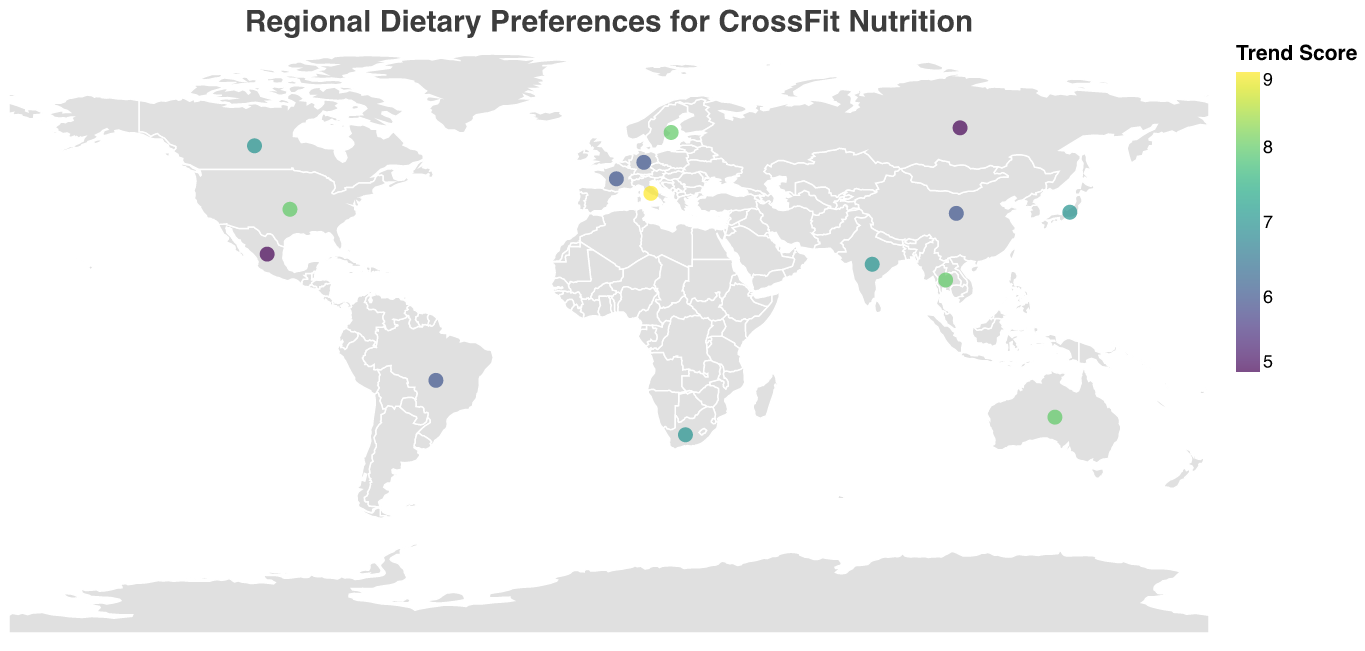How many countries have a trend score of 8? By examining the "Trend Score" colors in the legend and counting the corresponding circles on the map, we determine the countries with a trend score of 8. These are USA, Australia, Sweden, and Thailand.
Answer: 4 Which country in Europe has the highest trend score? By looking at the European section of the plot and comparing the trend scores, Italy stands out with a score of 9.
Answer: Italy What is the recommended CrossFit nutrition for athletes in India? By locating India on the map and checking its tooltip, the recommended nutrition is displayed as plant-based proteins and lentils.
Answer: Plant-based proteins and lentils Compare the dietary preference of Canada and Mexico. By examining the plot and reading the tooltip for each country, Canada's dietary preference is listed as gluten-free, while Mexico's is high fat.
Answer: Gluten-free and High fat Which region features a country with a "Spice-rich" dietary preference? By searching the dietary preferences in the tooltip, Thailand in Southeast Asia is listed with a "Spice-rich" dietary preference.
Answer: Southeast Asia Calculate the average trend score for North American countries. Identifying North American countries (USA, Canada, Mexico) and their scores (8, 7, 5). Average = (8 + 7 + 5) / 3 = 20 / 3 ≈ 6.67.
Answer: 6.67 What is the common nutritional recommendation for European countries? By reviewing European countries and their recommended nutrition, several are suggested to consume whole grains (Italy, Germany, France).
Answer: Whole grains Which country in Oceania has a trend score of 8, and what is its dietary preference? By checking the Oceania region on the plot, Australia has a trend score of 8, with a dietary preference of Paleo-inspired.
Answer: Australia, Paleo-inspired Identify the country with the lowest trend score and its corresponding nutritional advice. By scanning the plot for the lowest trend score, Mexico and Russia both have the lowest score of 5. Mexico’s advice is avocado and coconut oil; Russia’s is kefir and high-quality dairy proteins.
Answer: Two possible answers: Mexico, Avocado and coconut oil; Russia, Kefir and high-quality dairy proteins 